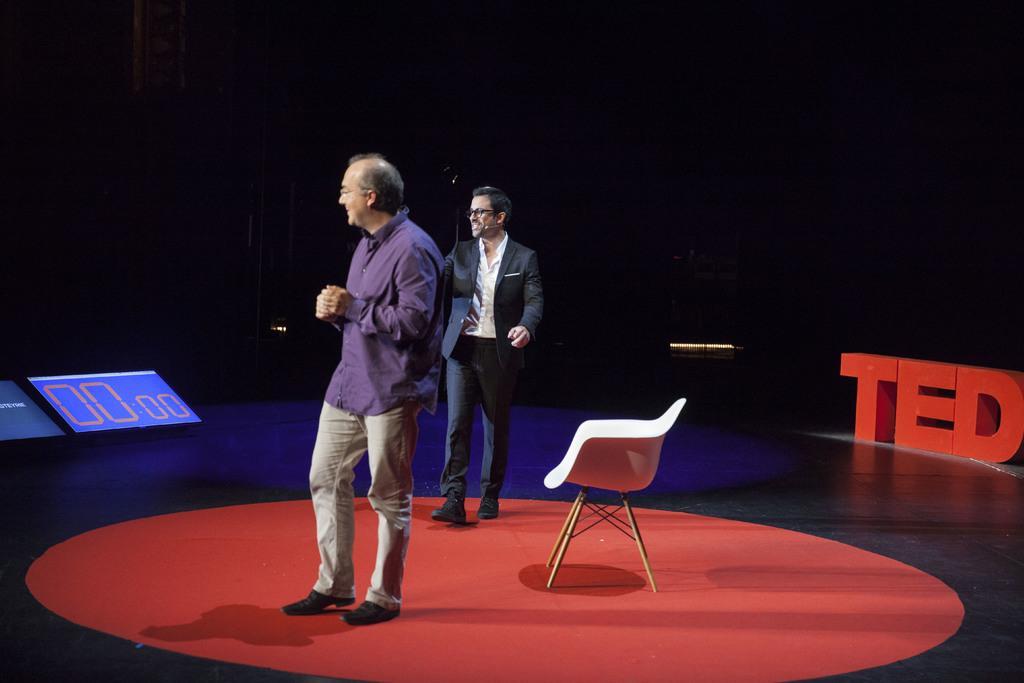Describe this image in one or two sentences. In this picture there is a man standing and his holding his hands, there is another person walking behind and his smiling there is a timer number display on the dais 